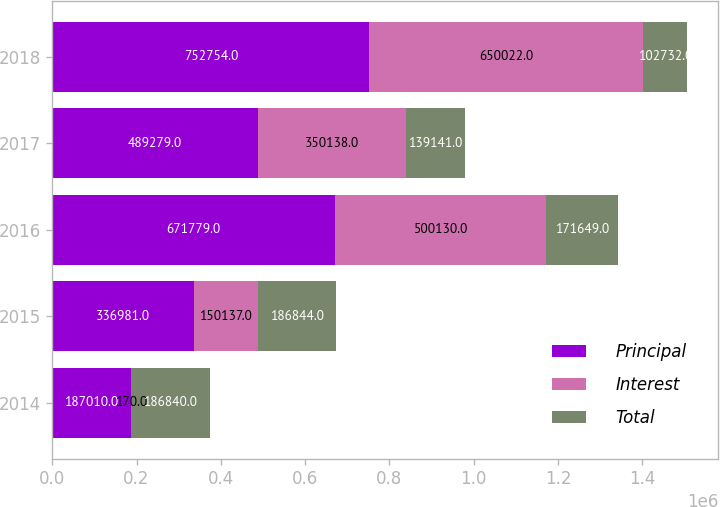Convert chart to OTSL. <chart><loc_0><loc_0><loc_500><loc_500><stacked_bar_chart><ecel><fcel>2014<fcel>2015<fcel>2016<fcel>2017<fcel>2018<nl><fcel>Principal<fcel>187010<fcel>336981<fcel>671779<fcel>489279<fcel>752754<nl><fcel>Interest<fcel>170<fcel>150137<fcel>500130<fcel>350138<fcel>650022<nl><fcel>Total<fcel>186840<fcel>186844<fcel>171649<fcel>139141<fcel>102732<nl></chart> 